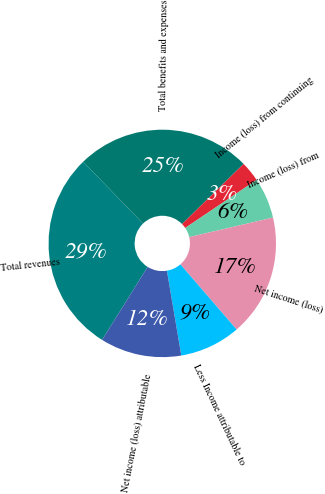<chart> <loc_0><loc_0><loc_500><loc_500><pie_chart><fcel>Total revenues<fcel>Total benefits and expenses<fcel>Income (loss) from continuing<fcel>Income (loss) from<fcel>Net income (loss)<fcel>Less Income attributable to<fcel>Net income (loss) attributable<nl><fcel>28.87%<fcel>24.93%<fcel>2.89%<fcel>5.78%<fcel>17.32%<fcel>8.66%<fcel>11.55%<nl></chart> 